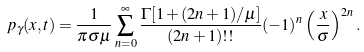Convert formula to latex. <formula><loc_0><loc_0><loc_500><loc_500>p _ { \gamma } ( x , t ) = \frac { 1 } { \pi \sigma \mu } \sum _ { n = 0 } ^ { \infty } \frac { \Gamma [ 1 + ( 2 n + 1 ) / \mu ] } { ( 2 n + 1 ) ! ! } ( - 1 ) ^ { n } \left ( \frac { x } { \sigma } \right ) ^ { 2 n } .</formula> 